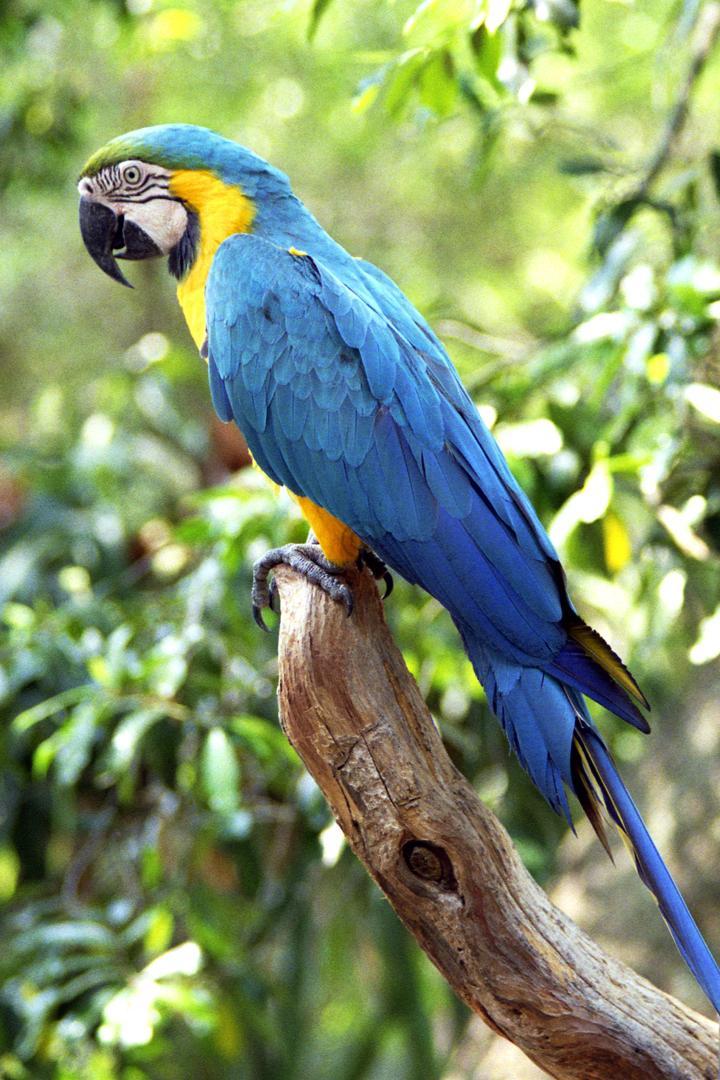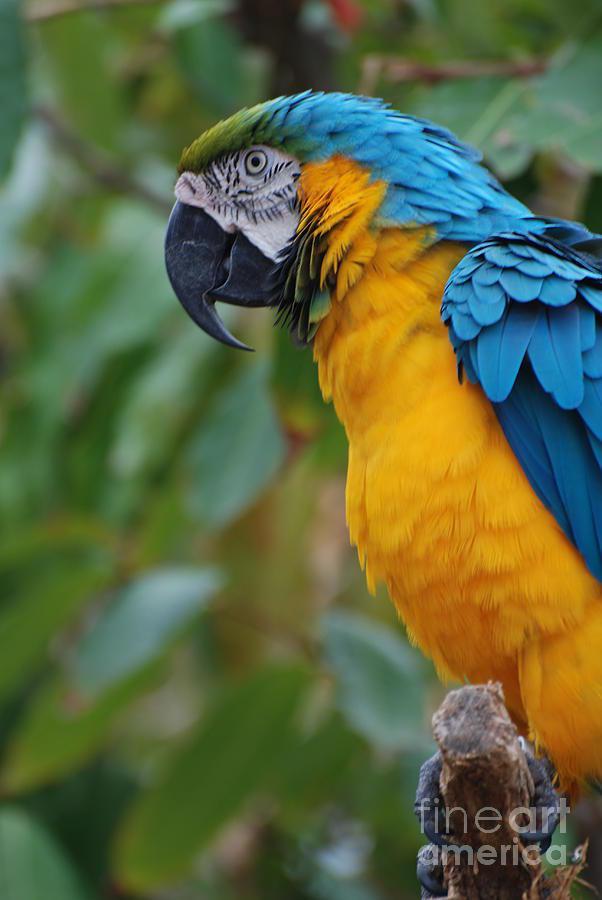The first image is the image on the left, the second image is the image on the right. Examine the images to the left and right. Is the description "There are two birds, each perched on a branch." accurate? Answer yes or no. Yes. The first image is the image on the left, the second image is the image on the right. Considering the images on both sides, is "There are two blue and yellow birds" valid? Answer yes or no. Yes. 